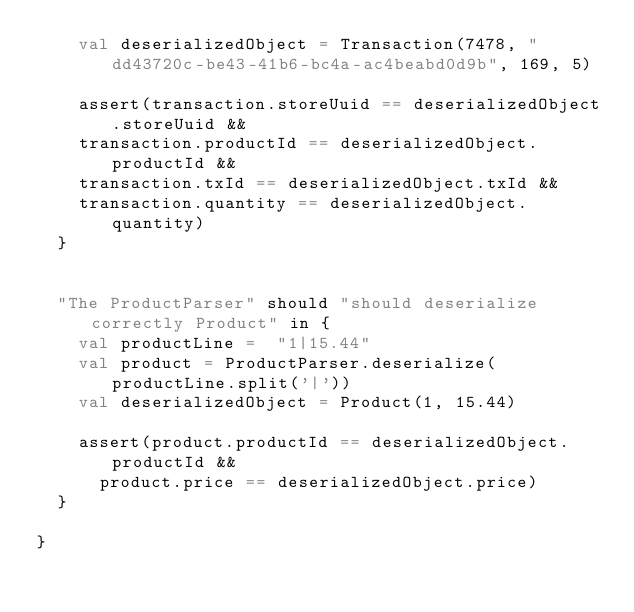<code> <loc_0><loc_0><loc_500><loc_500><_Scala_>    val deserializedObject = Transaction(7478, "dd43720c-be43-41b6-bc4a-ac4beabd0d9b", 169, 5)

    assert(transaction.storeUuid == deserializedObject.storeUuid &&
    transaction.productId == deserializedObject.productId &&
    transaction.txId == deserializedObject.txId &&
    transaction.quantity == deserializedObject.quantity)
  }


  "The ProductParser" should "should deserialize correctly Product" in {
    val productLine =  "1|15.44"
    val product = ProductParser.deserialize(productLine.split('|'))
    val deserializedObject = Product(1, 15.44)

    assert(product.productId == deserializedObject.productId &&
      product.price == deserializedObject.price)
  }

}
</code> 